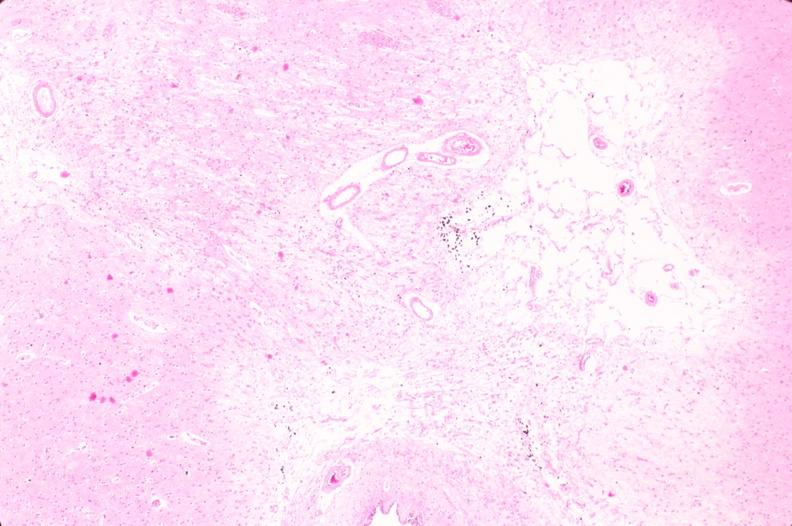where is this?
Answer the question using a single word or phrase. Nervous 